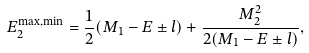Convert formula to latex. <formula><loc_0><loc_0><loc_500><loc_500>E _ { 2 } ^ { \max , \min } = \frac { 1 } { 2 } ( M _ { 1 } - E \pm l ) + \frac { M _ { 2 } ^ { 2 } } { 2 ( M _ { 1 } - E \pm l ) } ,</formula> 